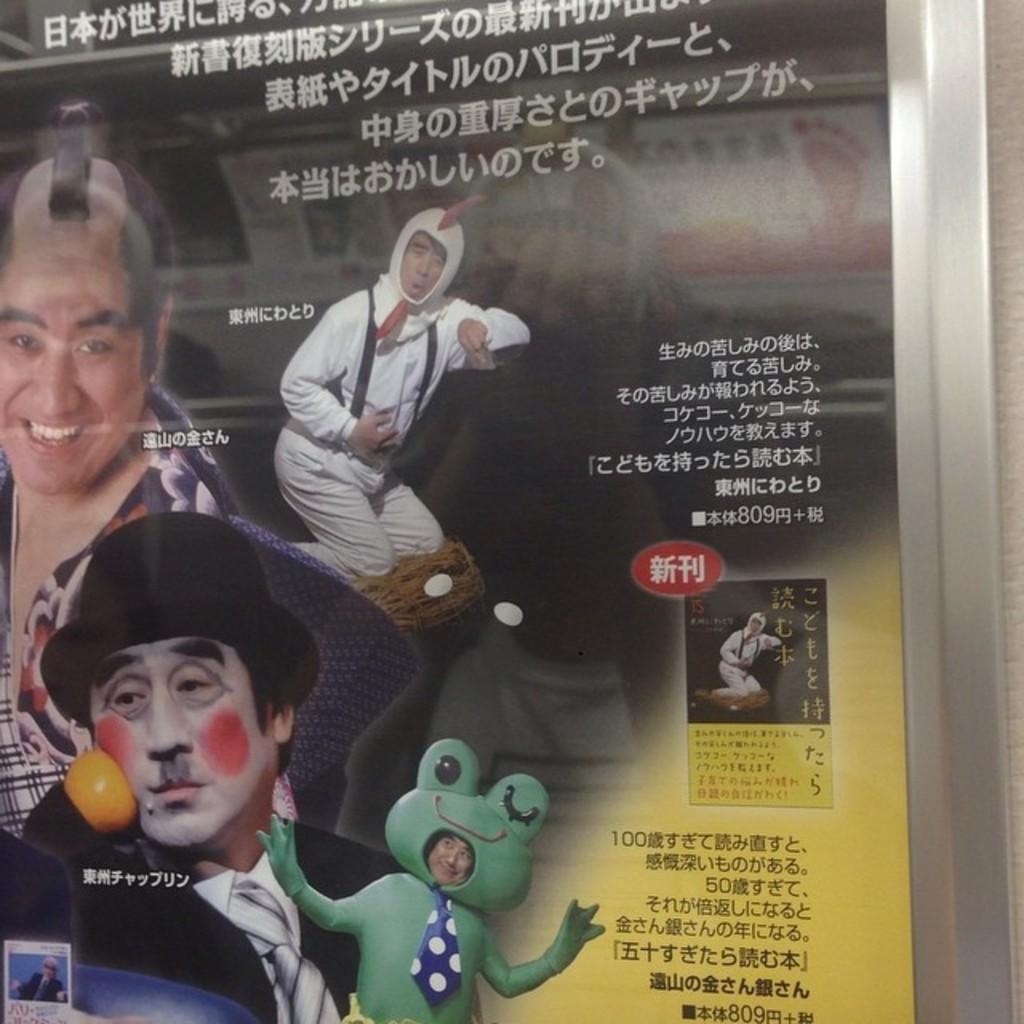Describe this image in one or two sentences. In this picture we can see a poster. There are few people visible on this poster. 